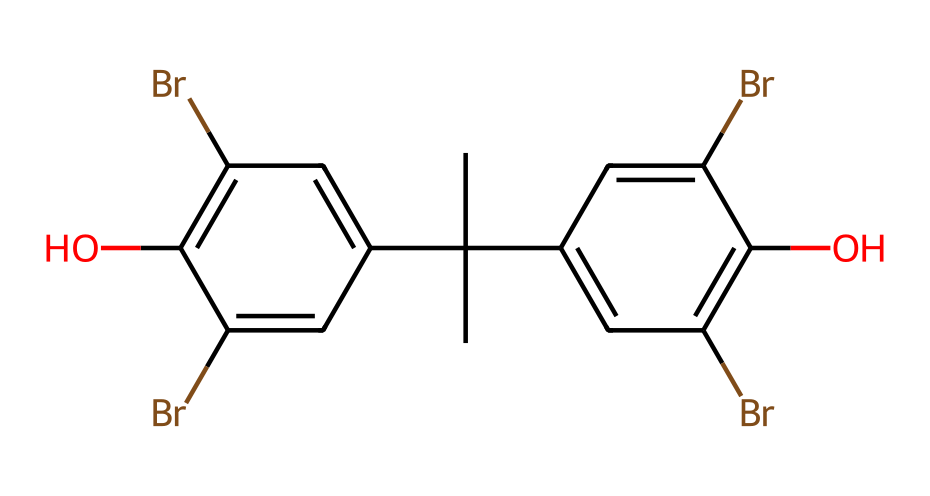What is the molecular formula of this compound? To derive the molecular formula, we can count the number of each type of atom in the SMILES notation. The structure depicts carbon (C), hydrogen (H), bromine (Br), and oxygen (O) atoms. Specifically, there are 18 carbon atoms, 14 hydrogen atoms, 4 bromine atoms, and 2 oxygen atoms. Therefore, the molecular formula is C18H14Br4O2.
Answer: C18H14Br4O2 How many bromine atoms are present in the structure? By examining the SMILES representation, we can identify bromine atoms indicated by the letters 'Br'. There are four occurrences of 'Br', confirming that there are four bromine atoms in the structure.
Answer: 4 What functional groups can be identified in this molecule? Observing the structure, we can identify the presence of hydroxyl (-OH) groups and the presence of aromatic rings. The hydroxyl groups are represented by 'O' attached to the carbon chain, hence confirming their presence as functional groups.
Answer: hydroxyl groups Is this compound a monomer or a polymer? By definition, a monomer is a small molecule that can join together to form polymers. This structure appears to be complex but is designed for flame retardancy, suggesting it functions as a monomer or building block in polymerization.
Answer: monomer What type of intermolecular forces are likely to be present due to the functional groups? The presence of hydroxyl groups suggests hydrogen bonding potential, which is a strong intermolecular force, alongside van der Waals forces due to the non-polar carbon chains. These interactions imply that both hydrogen bonding and van der Waals forces exist in this molecule.
Answer: hydrogen bonding How many rings are present in the structure? By inspecting the chemical structure, we can see that there are two aromatic rings present, evidenced by the cyclic arrangement of carbon atoms indicated in the SMILES notation.
Answer: 2 